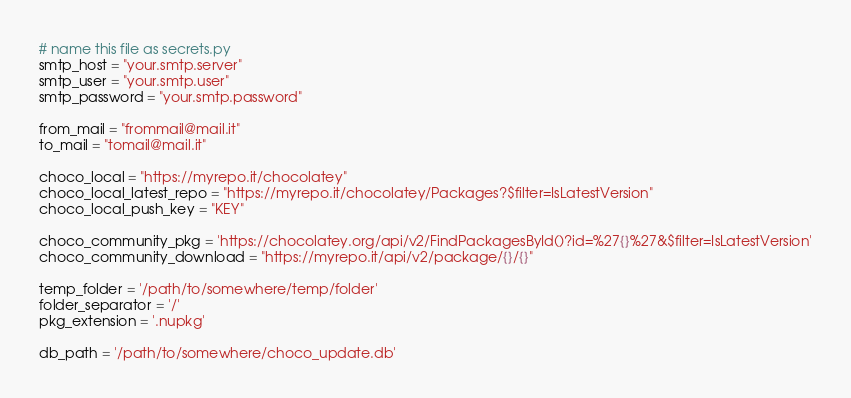<code> <loc_0><loc_0><loc_500><loc_500><_Python_># name this file as secrets.py
smtp_host = "your.smtp.server"
smtp_user = "your.smtp.user"
smtp_password = "your.smtp.password"

from_mail = "frommail@mail.it"
to_mail = "tomail@mail.it"

choco_local = "https://myrepo.it/chocolatey" 
choco_local_latest_repo = "https://myrepo.it/chocolatey/Packages?$filter=IsLatestVersion"
choco_local_push_key = "KEY"

choco_community_pkg = 'https://chocolatey.org/api/v2/FindPackagesById()?id=%27{}%27&$filter=IsLatestVersion'
choco_community_download = "https://myrepo.it/api/v2/package/{}/{}"

temp_folder = '/path/to/somewhere/temp/folder'
folder_separator = '/'
pkg_extension = '.nupkg'

db_path = '/path/to/somewhere/choco_update.db'
</code> 